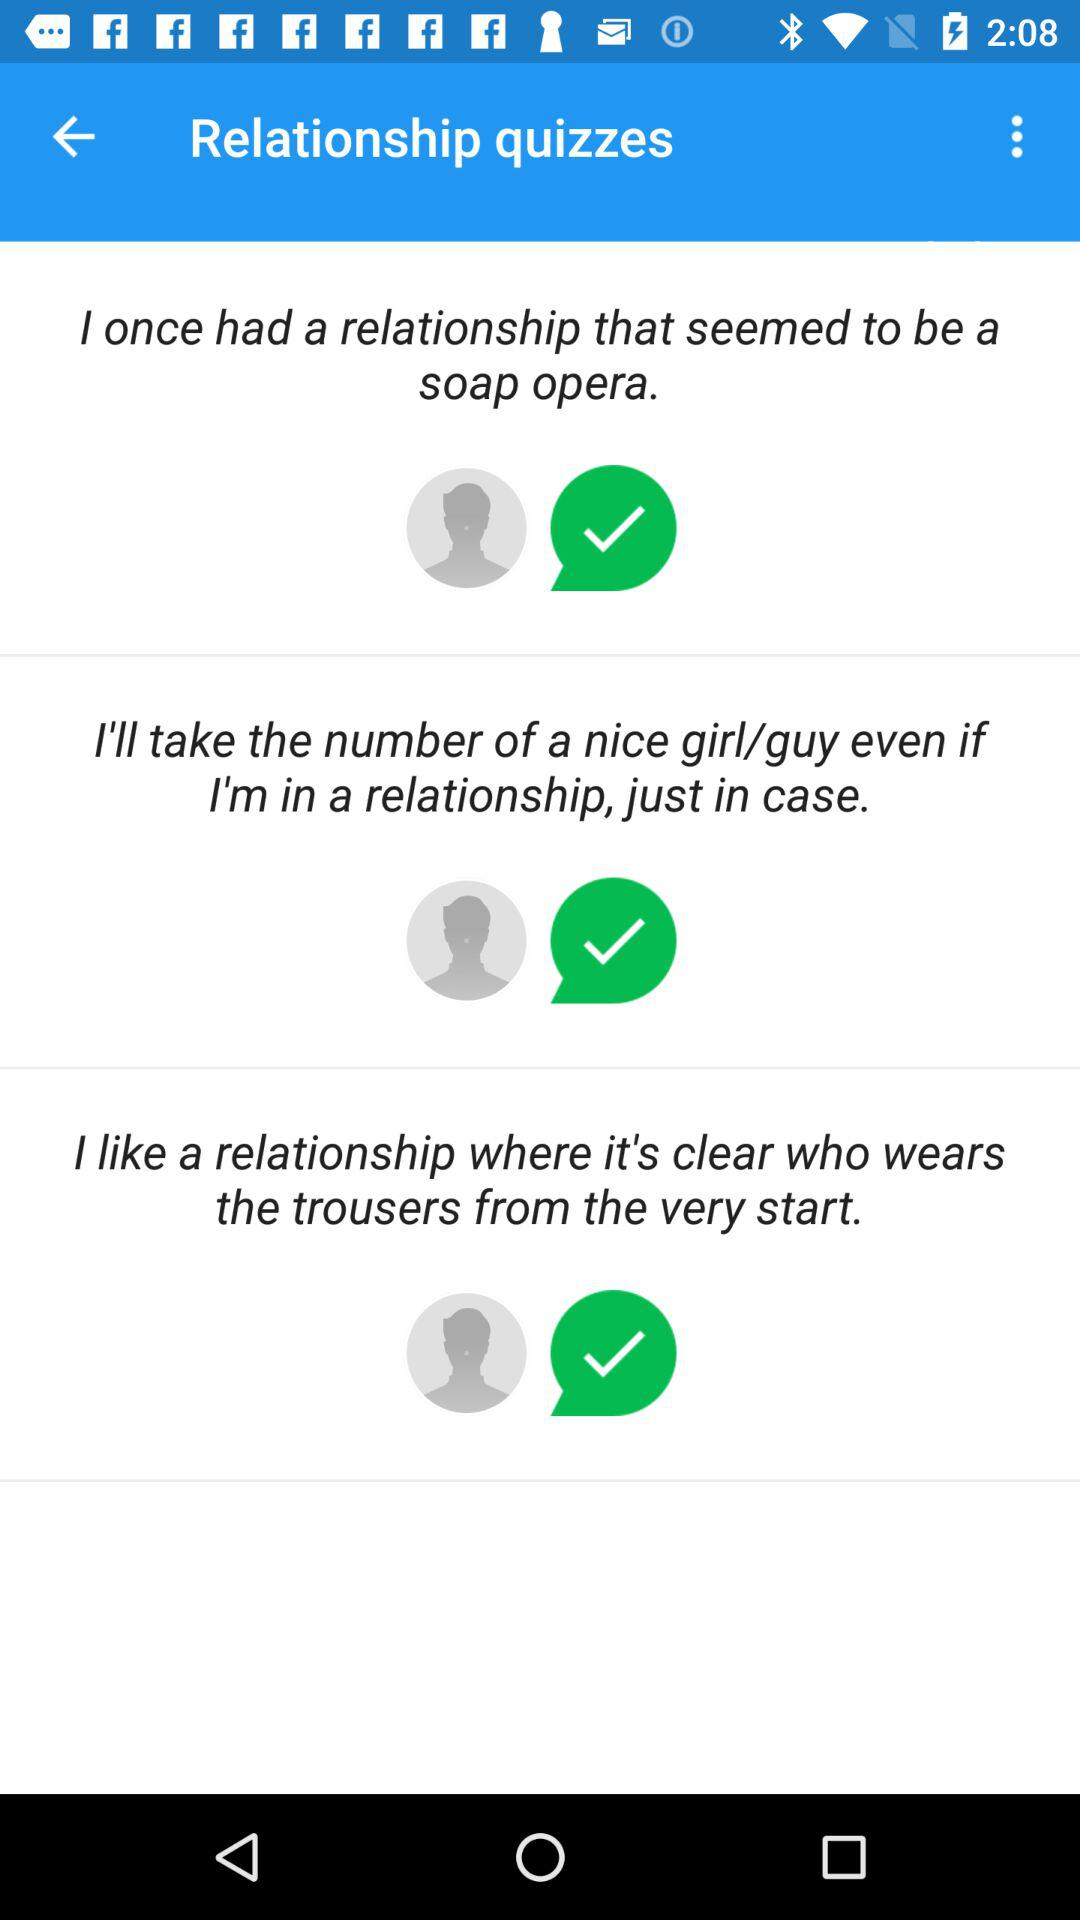How many relationship quizzes are there?
Answer the question using a single word or phrase. 3 